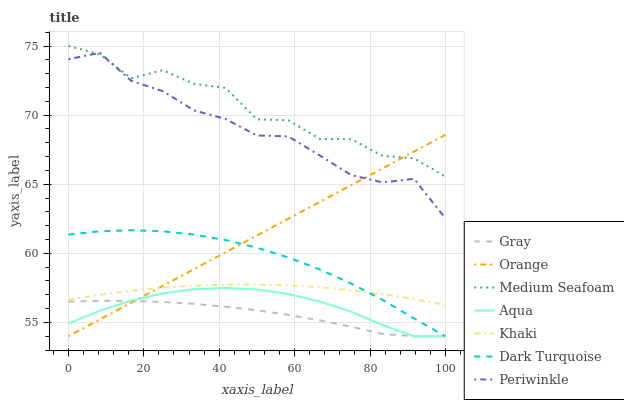Does Gray have the minimum area under the curve?
Answer yes or no. Yes. Does Medium Seafoam have the maximum area under the curve?
Answer yes or no. Yes. Does Khaki have the minimum area under the curve?
Answer yes or no. No. Does Khaki have the maximum area under the curve?
Answer yes or no. No. Is Orange the smoothest?
Answer yes or no. Yes. Is Medium Seafoam the roughest?
Answer yes or no. Yes. Is Khaki the smoothest?
Answer yes or no. No. Is Khaki the roughest?
Answer yes or no. No. Does Gray have the lowest value?
Answer yes or no. Yes. Does Khaki have the lowest value?
Answer yes or no. No. Does Medium Seafoam have the highest value?
Answer yes or no. Yes. Does Khaki have the highest value?
Answer yes or no. No. Is Aqua less than Periwinkle?
Answer yes or no. Yes. Is Medium Seafoam greater than Aqua?
Answer yes or no. Yes. Does Periwinkle intersect Medium Seafoam?
Answer yes or no. Yes. Is Periwinkle less than Medium Seafoam?
Answer yes or no. No. Is Periwinkle greater than Medium Seafoam?
Answer yes or no. No. Does Aqua intersect Periwinkle?
Answer yes or no. No. 